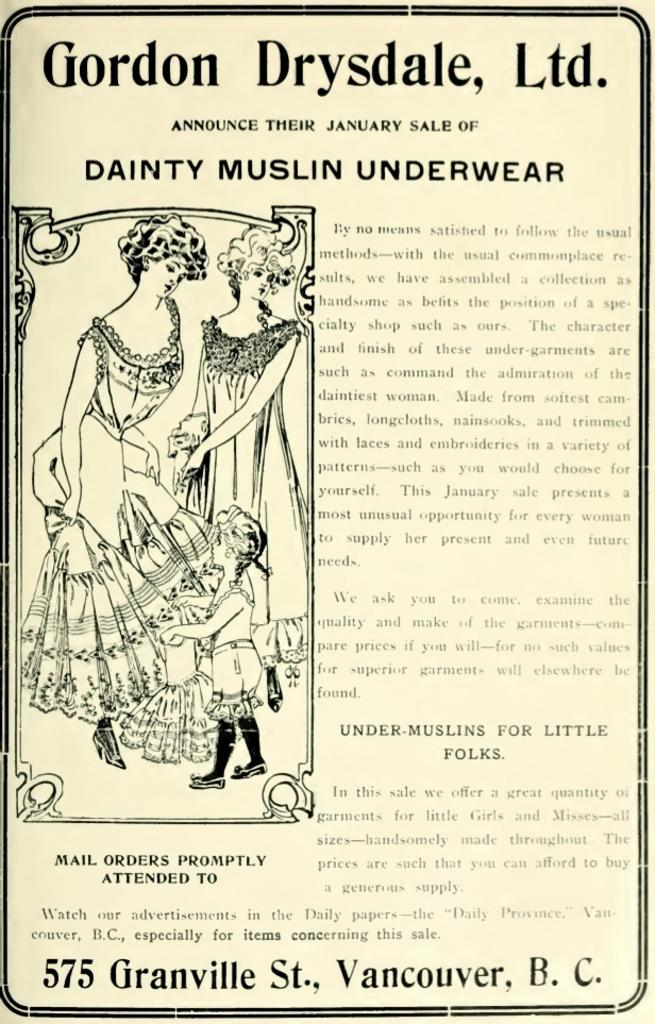What is the main subject of the poster in the image? The poster contains images of two ladies and a baby. What else can be seen on the poster besides the images? There is text on the poster. Can you tell me where the crow is sitting on the poster? There is no crow present on the poster; it only contains images of two ladies and a baby, along with text. 